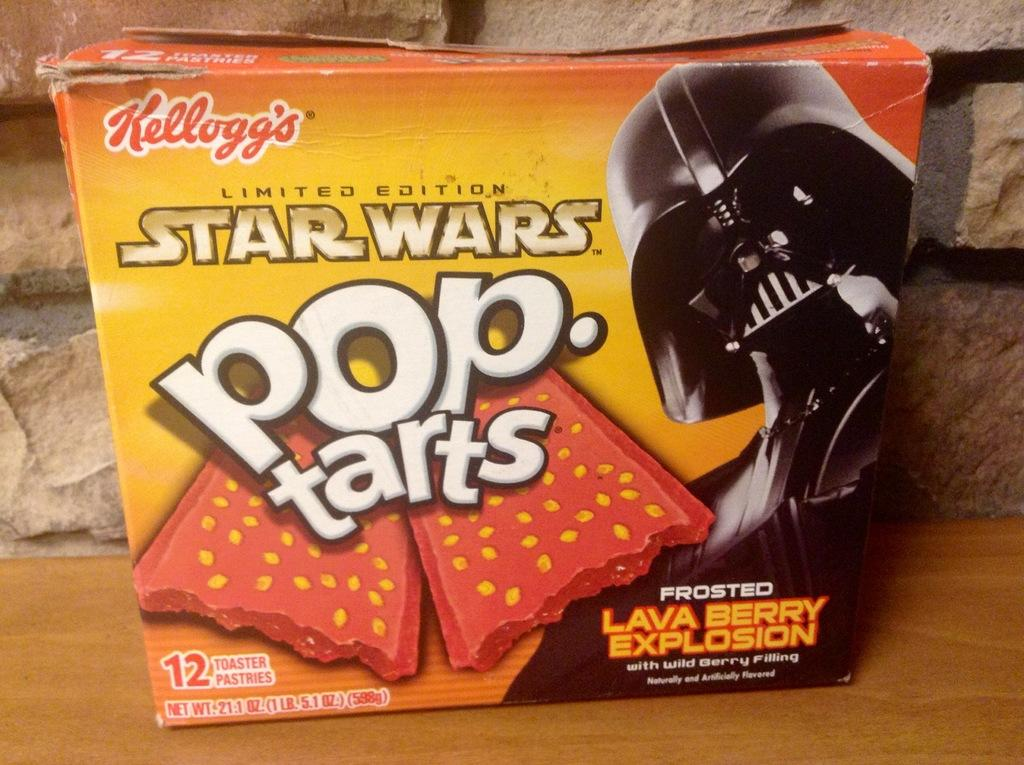What is on the box that is visible in the image? There is text and an image on the box. Where is the box located in the image? The box is on a wooden table. What else can be seen in the background of the image? There is a wall visible in the image. How many heads of lettuce are on the screw in the image? There is no screw or lettuce present in the image. 